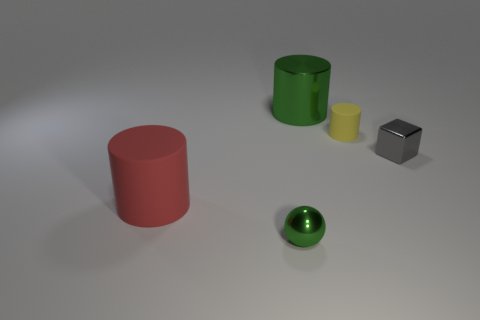Subtract all brown cubes. Subtract all yellow spheres. How many cubes are left? 1 Add 4 blue spheres. How many objects exist? 9 Subtract all cubes. How many objects are left? 4 Subtract 0 blue blocks. How many objects are left? 5 Subtract all metallic spheres. Subtract all tiny brown metal blocks. How many objects are left? 4 Add 4 red cylinders. How many red cylinders are left? 5 Add 4 gray cubes. How many gray cubes exist? 5 